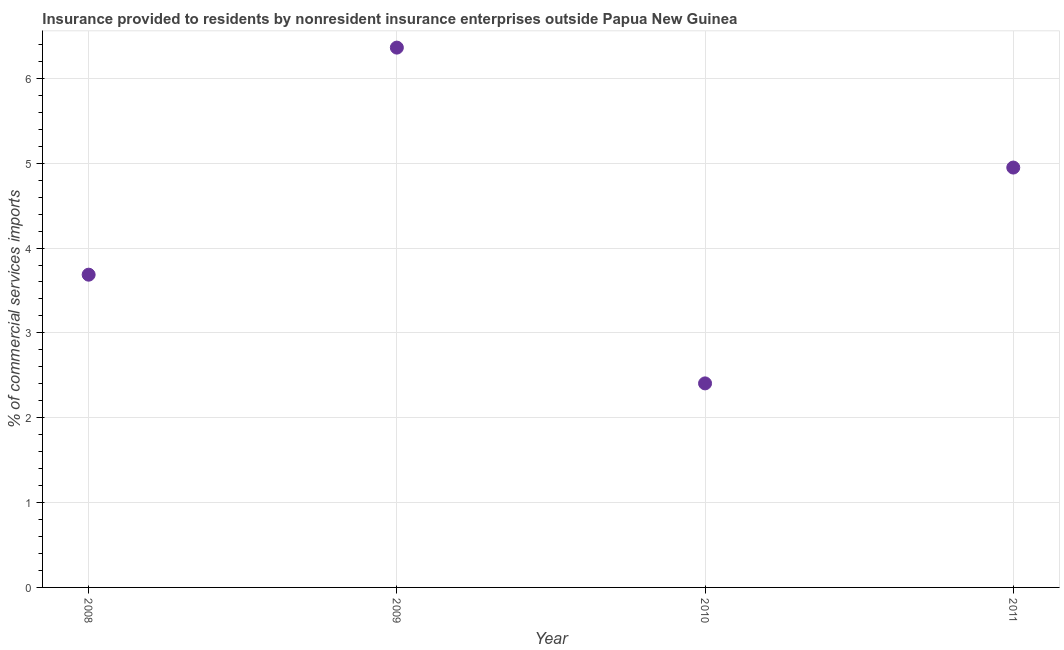What is the insurance provided by non-residents in 2008?
Your response must be concise. 3.69. Across all years, what is the maximum insurance provided by non-residents?
Your response must be concise. 6.36. Across all years, what is the minimum insurance provided by non-residents?
Offer a very short reply. 2.4. In which year was the insurance provided by non-residents minimum?
Give a very brief answer. 2010. What is the sum of the insurance provided by non-residents?
Your answer should be compact. 17.4. What is the difference between the insurance provided by non-residents in 2010 and 2011?
Provide a succinct answer. -2.54. What is the average insurance provided by non-residents per year?
Provide a succinct answer. 4.35. What is the median insurance provided by non-residents?
Give a very brief answer. 4.32. In how many years, is the insurance provided by non-residents greater than 0.4 %?
Make the answer very short. 4. Do a majority of the years between 2010 and 2008 (inclusive) have insurance provided by non-residents greater than 2.8 %?
Keep it short and to the point. No. What is the ratio of the insurance provided by non-residents in 2008 to that in 2009?
Give a very brief answer. 0.58. Is the difference between the insurance provided by non-residents in 2009 and 2010 greater than the difference between any two years?
Make the answer very short. Yes. What is the difference between the highest and the second highest insurance provided by non-residents?
Give a very brief answer. 1.41. What is the difference between the highest and the lowest insurance provided by non-residents?
Your answer should be compact. 3.96. Does the insurance provided by non-residents monotonically increase over the years?
Your answer should be very brief. No. How many dotlines are there?
Ensure brevity in your answer.  1. How many years are there in the graph?
Give a very brief answer. 4. What is the difference between two consecutive major ticks on the Y-axis?
Provide a succinct answer. 1. Does the graph contain any zero values?
Your answer should be very brief. No. Does the graph contain grids?
Give a very brief answer. Yes. What is the title of the graph?
Your answer should be compact. Insurance provided to residents by nonresident insurance enterprises outside Papua New Guinea. What is the label or title of the Y-axis?
Keep it short and to the point. % of commercial services imports. What is the % of commercial services imports in 2008?
Your response must be concise. 3.69. What is the % of commercial services imports in 2009?
Offer a terse response. 6.36. What is the % of commercial services imports in 2010?
Offer a terse response. 2.4. What is the % of commercial services imports in 2011?
Your response must be concise. 4.95. What is the difference between the % of commercial services imports in 2008 and 2009?
Your response must be concise. -2.68. What is the difference between the % of commercial services imports in 2008 and 2010?
Provide a succinct answer. 1.28. What is the difference between the % of commercial services imports in 2008 and 2011?
Offer a very short reply. -1.26. What is the difference between the % of commercial services imports in 2009 and 2010?
Keep it short and to the point. 3.96. What is the difference between the % of commercial services imports in 2009 and 2011?
Your response must be concise. 1.41. What is the difference between the % of commercial services imports in 2010 and 2011?
Keep it short and to the point. -2.54. What is the ratio of the % of commercial services imports in 2008 to that in 2009?
Your answer should be very brief. 0.58. What is the ratio of the % of commercial services imports in 2008 to that in 2010?
Offer a terse response. 1.53. What is the ratio of the % of commercial services imports in 2008 to that in 2011?
Your answer should be compact. 0.74. What is the ratio of the % of commercial services imports in 2009 to that in 2010?
Offer a terse response. 2.65. What is the ratio of the % of commercial services imports in 2009 to that in 2011?
Provide a short and direct response. 1.29. What is the ratio of the % of commercial services imports in 2010 to that in 2011?
Give a very brief answer. 0.49. 